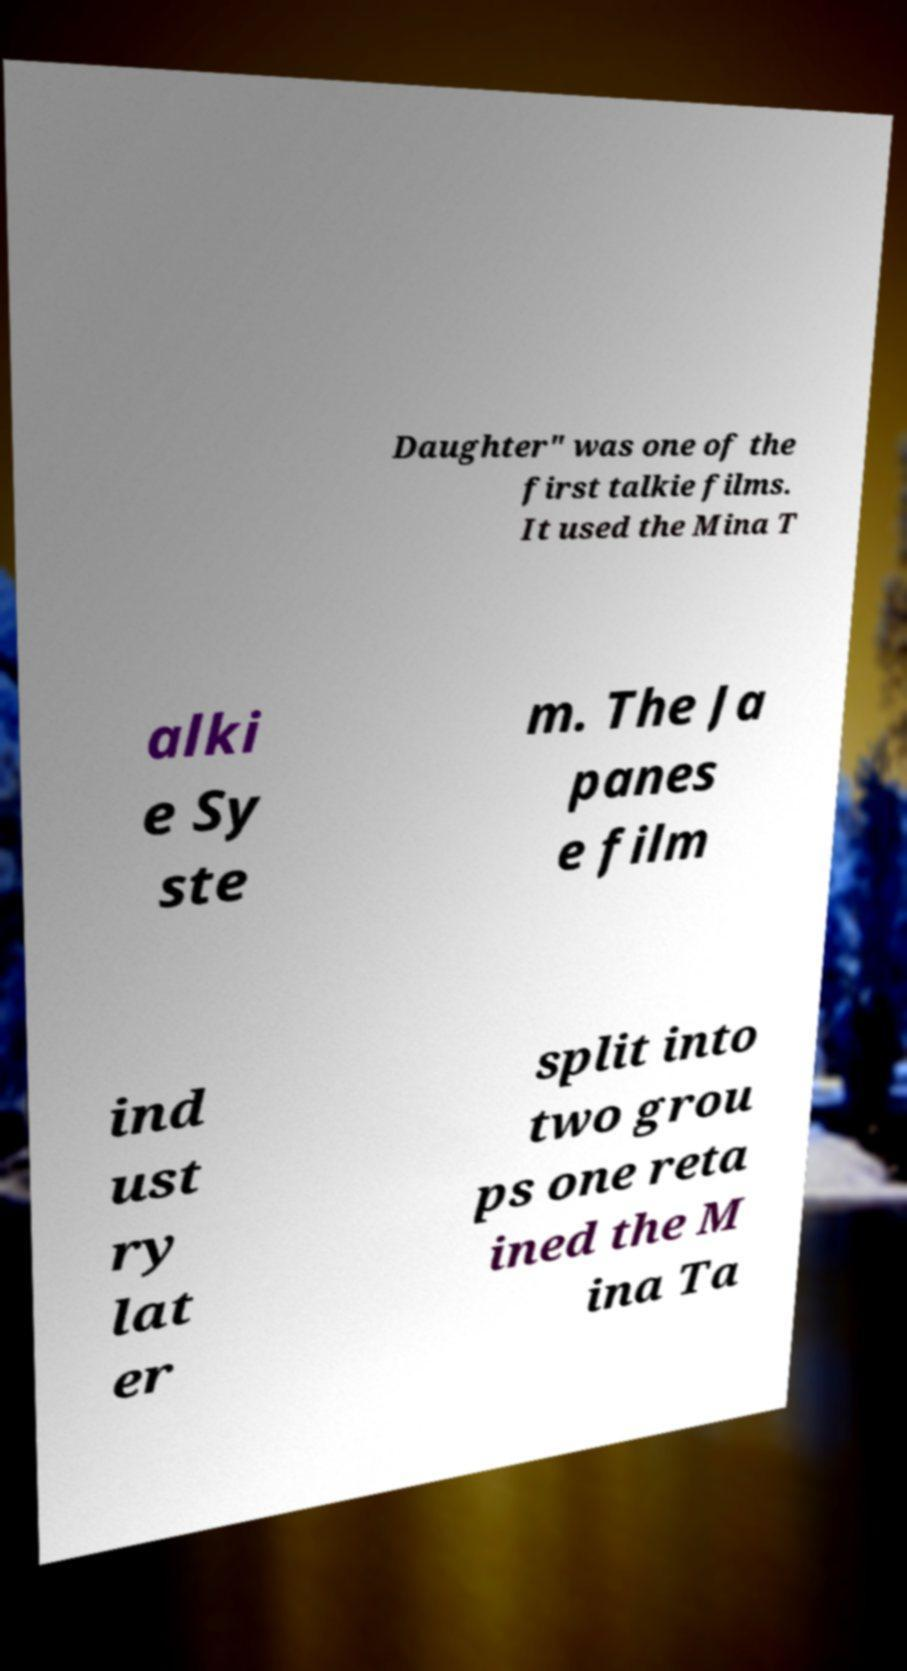Could you assist in decoding the text presented in this image and type it out clearly? Daughter" was one of the first talkie films. It used the Mina T alki e Sy ste m. The Ja panes e film ind ust ry lat er split into two grou ps one reta ined the M ina Ta 